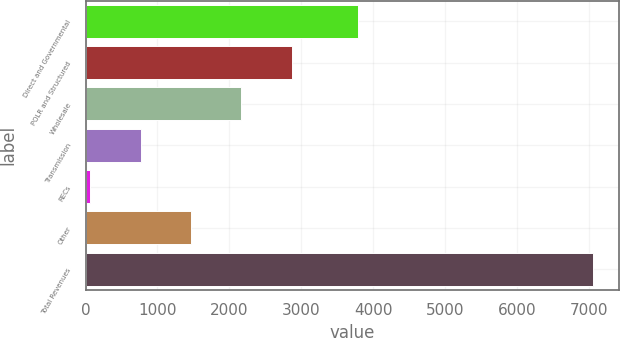Convert chart to OTSL. <chart><loc_0><loc_0><loc_500><loc_500><bar_chart><fcel>Direct and Governmental<fcel>POLR and Structured<fcel>Wholesale<fcel>Transmission<fcel>RECs<fcel>Other<fcel>Total Revenues<nl><fcel>3785<fcel>2865<fcel>2165.5<fcel>766.5<fcel>67<fcel>1466<fcel>7062<nl></chart> 